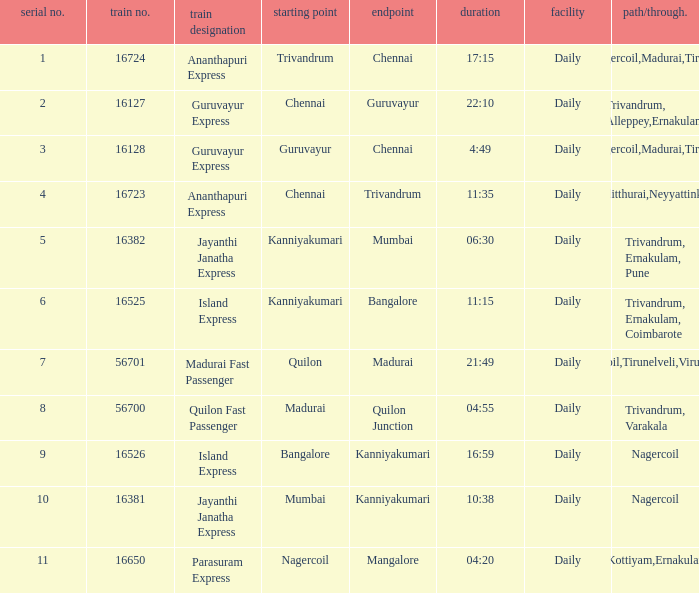What is the route/via when the destination is listed as Madurai? Nagercoil,Tirunelveli,Virudunagar. 